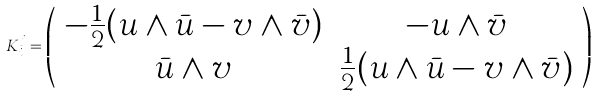<formula> <loc_0><loc_0><loc_500><loc_500>K _ { i } ^ { j } = \left ( \begin{array} { c c } { - { \frac { 1 } { 2 } } } ( u \wedge \bar { u } - v \wedge \bar { v } ) & - u \wedge \bar { v } \\ \bar { u } \wedge v & { { \frac { 1 } { 2 } } } ( u \wedge \bar { u } - v \wedge \bar { v } ) \end{array} \right )</formula> 